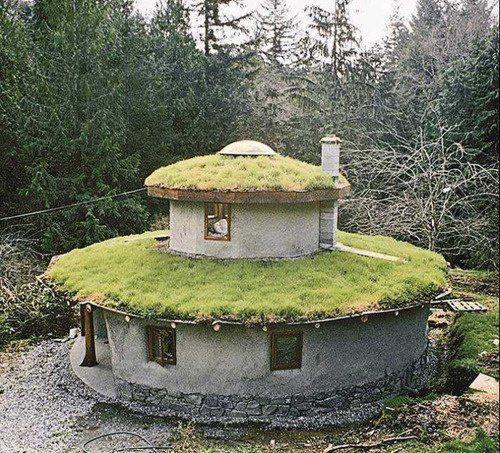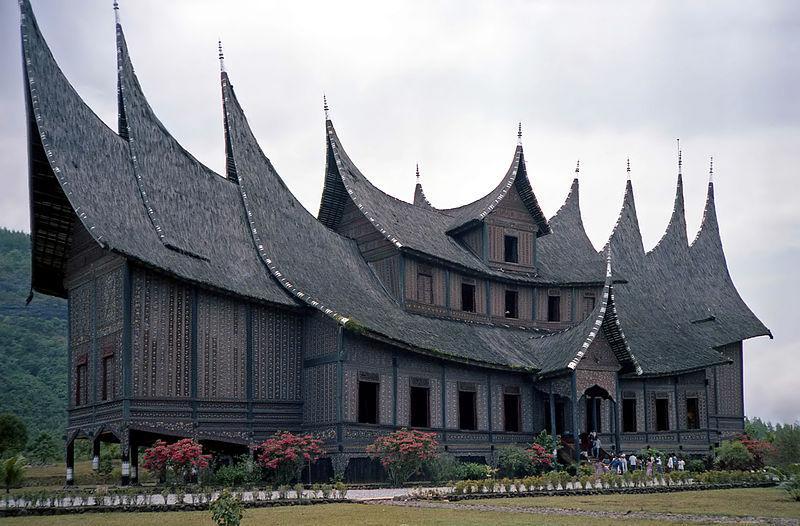The first image is the image on the left, the second image is the image on the right. Considering the images on both sides, is "The structures on the left and right are simple boxy shapes with peaked thatch roofs featuring some kind of top border, but no curves or notches." valid? Answer yes or no. No. 